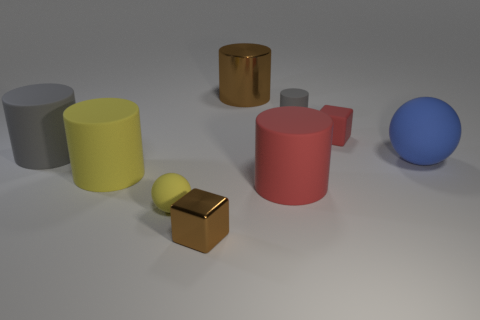Subtract all large gray rubber cylinders. How many cylinders are left? 4 Subtract all brown cylinders. How many cylinders are left? 4 Subtract all blue cylinders. Subtract all purple balls. How many cylinders are left? 5 Add 1 big red metallic things. How many objects exist? 10 Subtract all cylinders. How many objects are left? 4 Add 8 large cyan matte objects. How many large cyan matte objects exist? 8 Subtract 0 purple cylinders. How many objects are left? 9 Subtract all purple rubber cylinders. Subtract all red rubber blocks. How many objects are left? 8 Add 3 yellow matte things. How many yellow matte things are left? 5 